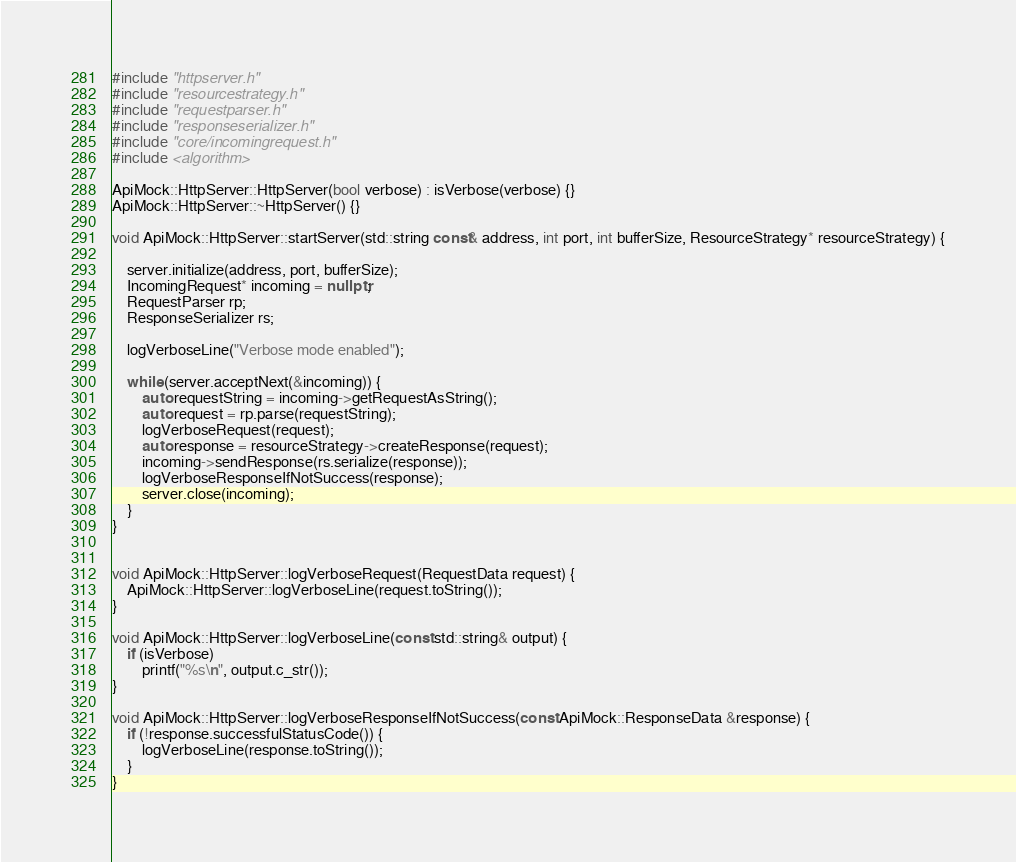Convert code to text. <code><loc_0><loc_0><loc_500><loc_500><_C++_>#include "httpserver.h"
#include "resourcestrategy.h"
#include "requestparser.h"
#include "responseserializer.h"
#include "core/incomingrequest.h"
#include <algorithm>

ApiMock::HttpServer::HttpServer(bool verbose) : isVerbose(verbose) {}
ApiMock::HttpServer::~HttpServer() {}

void ApiMock::HttpServer::startServer(std::string const& address, int port, int bufferSize, ResourceStrategy* resourceStrategy) {

	server.initialize(address, port, bufferSize);
	IncomingRequest* incoming = nullptr;
	RequestParser rp;
	ResponseSerializer rs;

	logVerboseLine("Verbose mode enabled");

	while (server.acceptNext(&incoming)) {
		auto requestString = incoming->getRequestAsString();
		auto request = rp.parse(requestString);
		logVerboseRequest(request);
		auto response = resourceStrategy->createResponse(request);
		incoming->sendResponse(rs.serialize(response));
		logVerboseResponseIfNotSuccess(response);
		server.close(incoming);
	}
}


void ApiMock::HttpServer::logVerboseRequest(RequestData request) {
	ApiMock::HttpServer::logVerboseLine(request.toString());
}

void ApiMock::HttpServer::logVerboseLine(const std::string& output) {
	if (isVerbose)
		printf("%s\n", output.c_str());
}

void ApiMock::HttpServer::logVerboseResponseIfNotSuccess(const ApiMock::ResponseData &response) {
	if (!response.successfulStatusCode()) {
		logVerboseLine(response.toString());
	}
}
</code> 